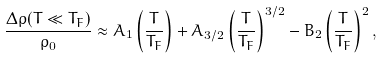<formula> <loc_0><loc_0><loc_500><loc_500>\frac { \Delta \rho ( T \ll T _ { F } ) } { \rho _ { 0 } } \approx A _ { 1 } \left ( \frac { T } { T _ { F } } \right ) + A _ { 3 / 2 } \left ( \frac { T } { T _ { F } } \right ) ^ { 3 / 2 } - B _ { 2 } \left ( \frac { T } { T _ { F } } \right ) ^ { 2 } ,</formula> 